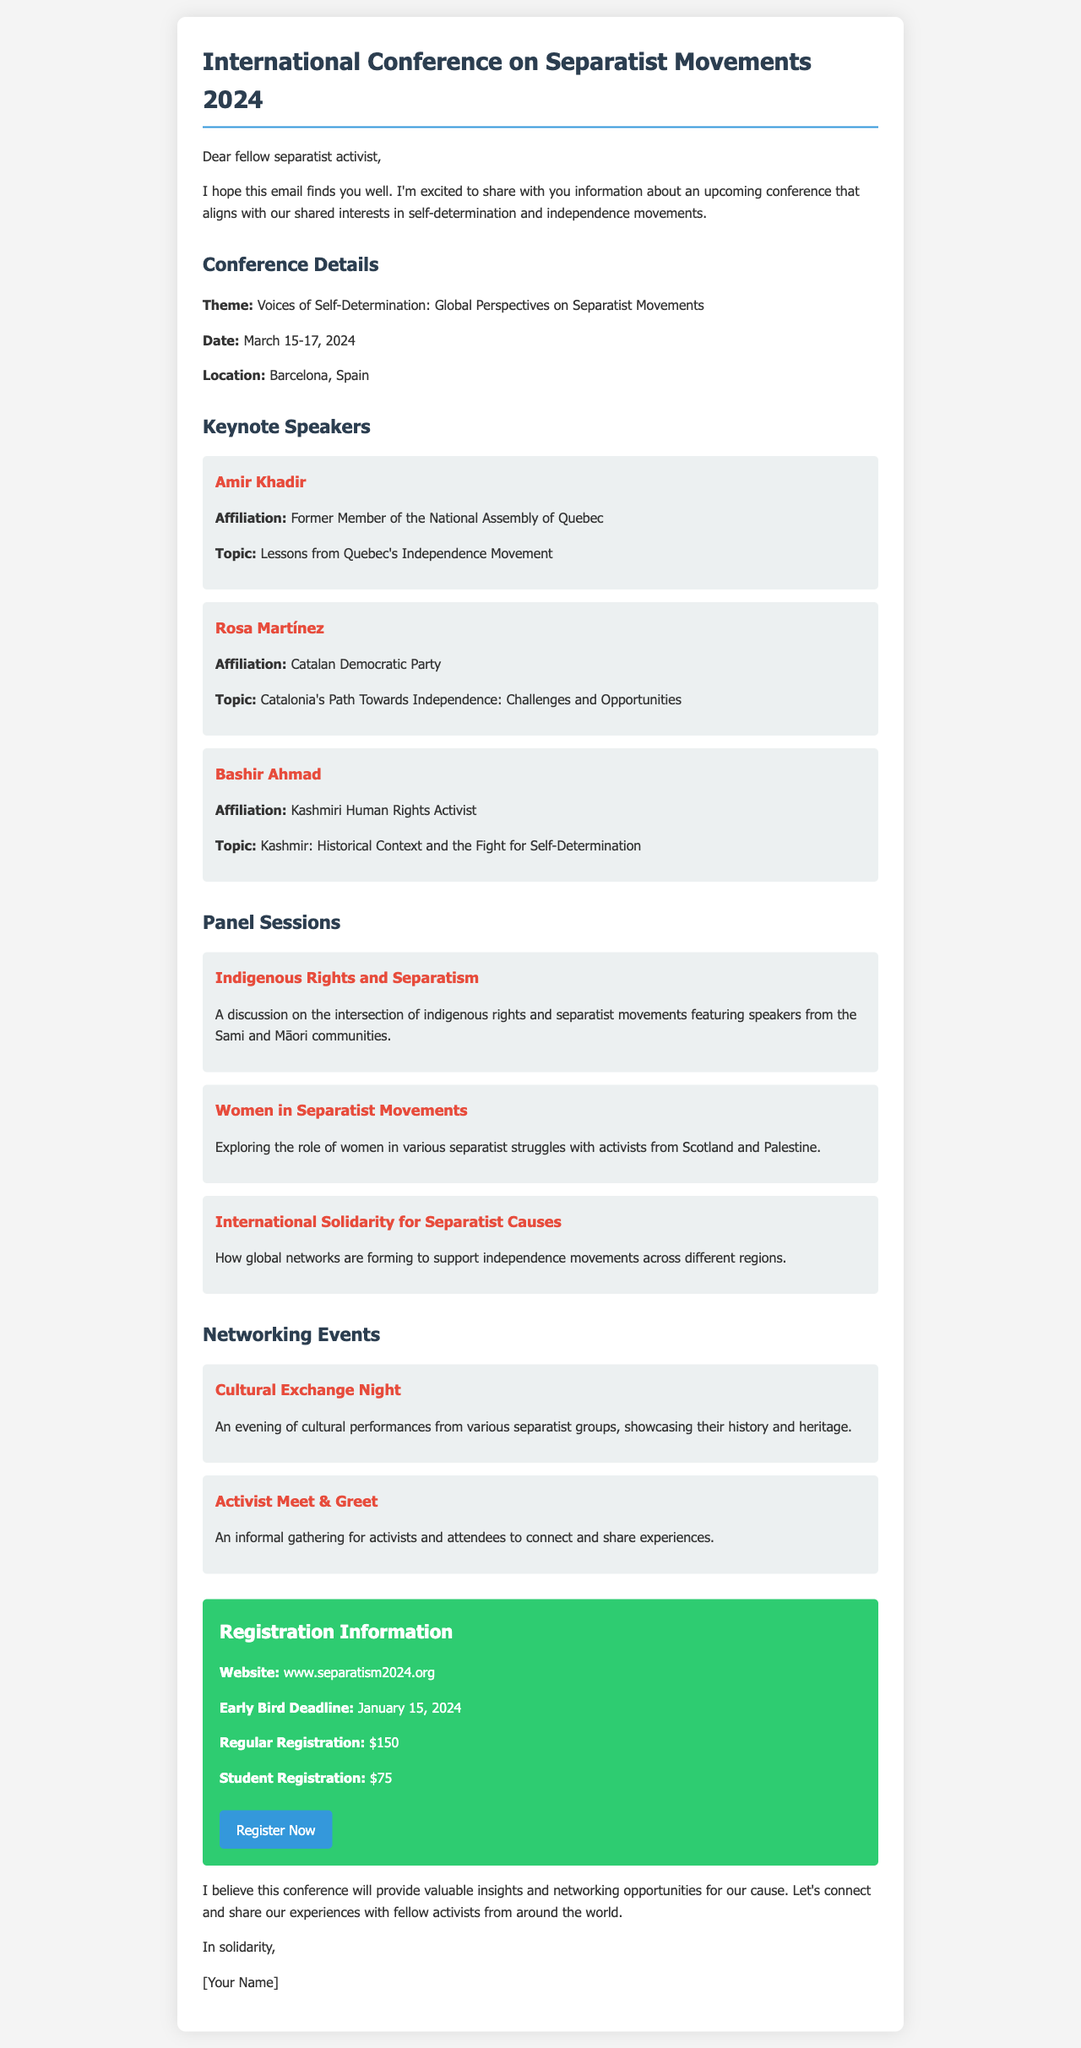what is the theme of the conference? The theme is mentioned in the conference details section as "Voices of Self-Determination: Global Perspectives on Separatist Movements."
Answer: Voices of Self-Determination: Global Perspectives on Separatist Movements when is the early bird registration deadline? The early bird registration deadline is specified in the registration information section as January 15, 2024.
Answer: January 15, 2024 who is the speaker discussing Kashmir? The speaker discussing Kashmir is identified in the keynote speakers section as Bashir Ahmad.
Answer: Bashir Ahmad what topic will Rosa Martínez speak on? Rosa Martínez's topic is stated in the keynote speakers section as "Catalonia's Path Towards Independence: Challenges and Opportunities."
Answer: Catalonia's Path Towards Independence: Challenges and Opportunities how many days will the conference last? The conference dates indicate it will last from March 15 to March 17, which is a total of three days.
Answer: 3 days what is the regular registration fee? The regular registration fee is provided in the registration information section as $150.
Answer: $150 which event features cultural performances? The event featuring cultural performances is identified in the networking events section as "Cultural Exchange Night."
Answer: Cultural Exchange Night what is the location of the conference? The location of the conference is listed in the conference details section as Barcelona, Spain.
Answer: Barcelona, Spain who is affiliated with the Sami and Māori communities in the panel sessions? The panel session about indigenous rights discusses speakers from the Sami and Māori communities, but no specific names are provided in the details.
Answer: Unknown 